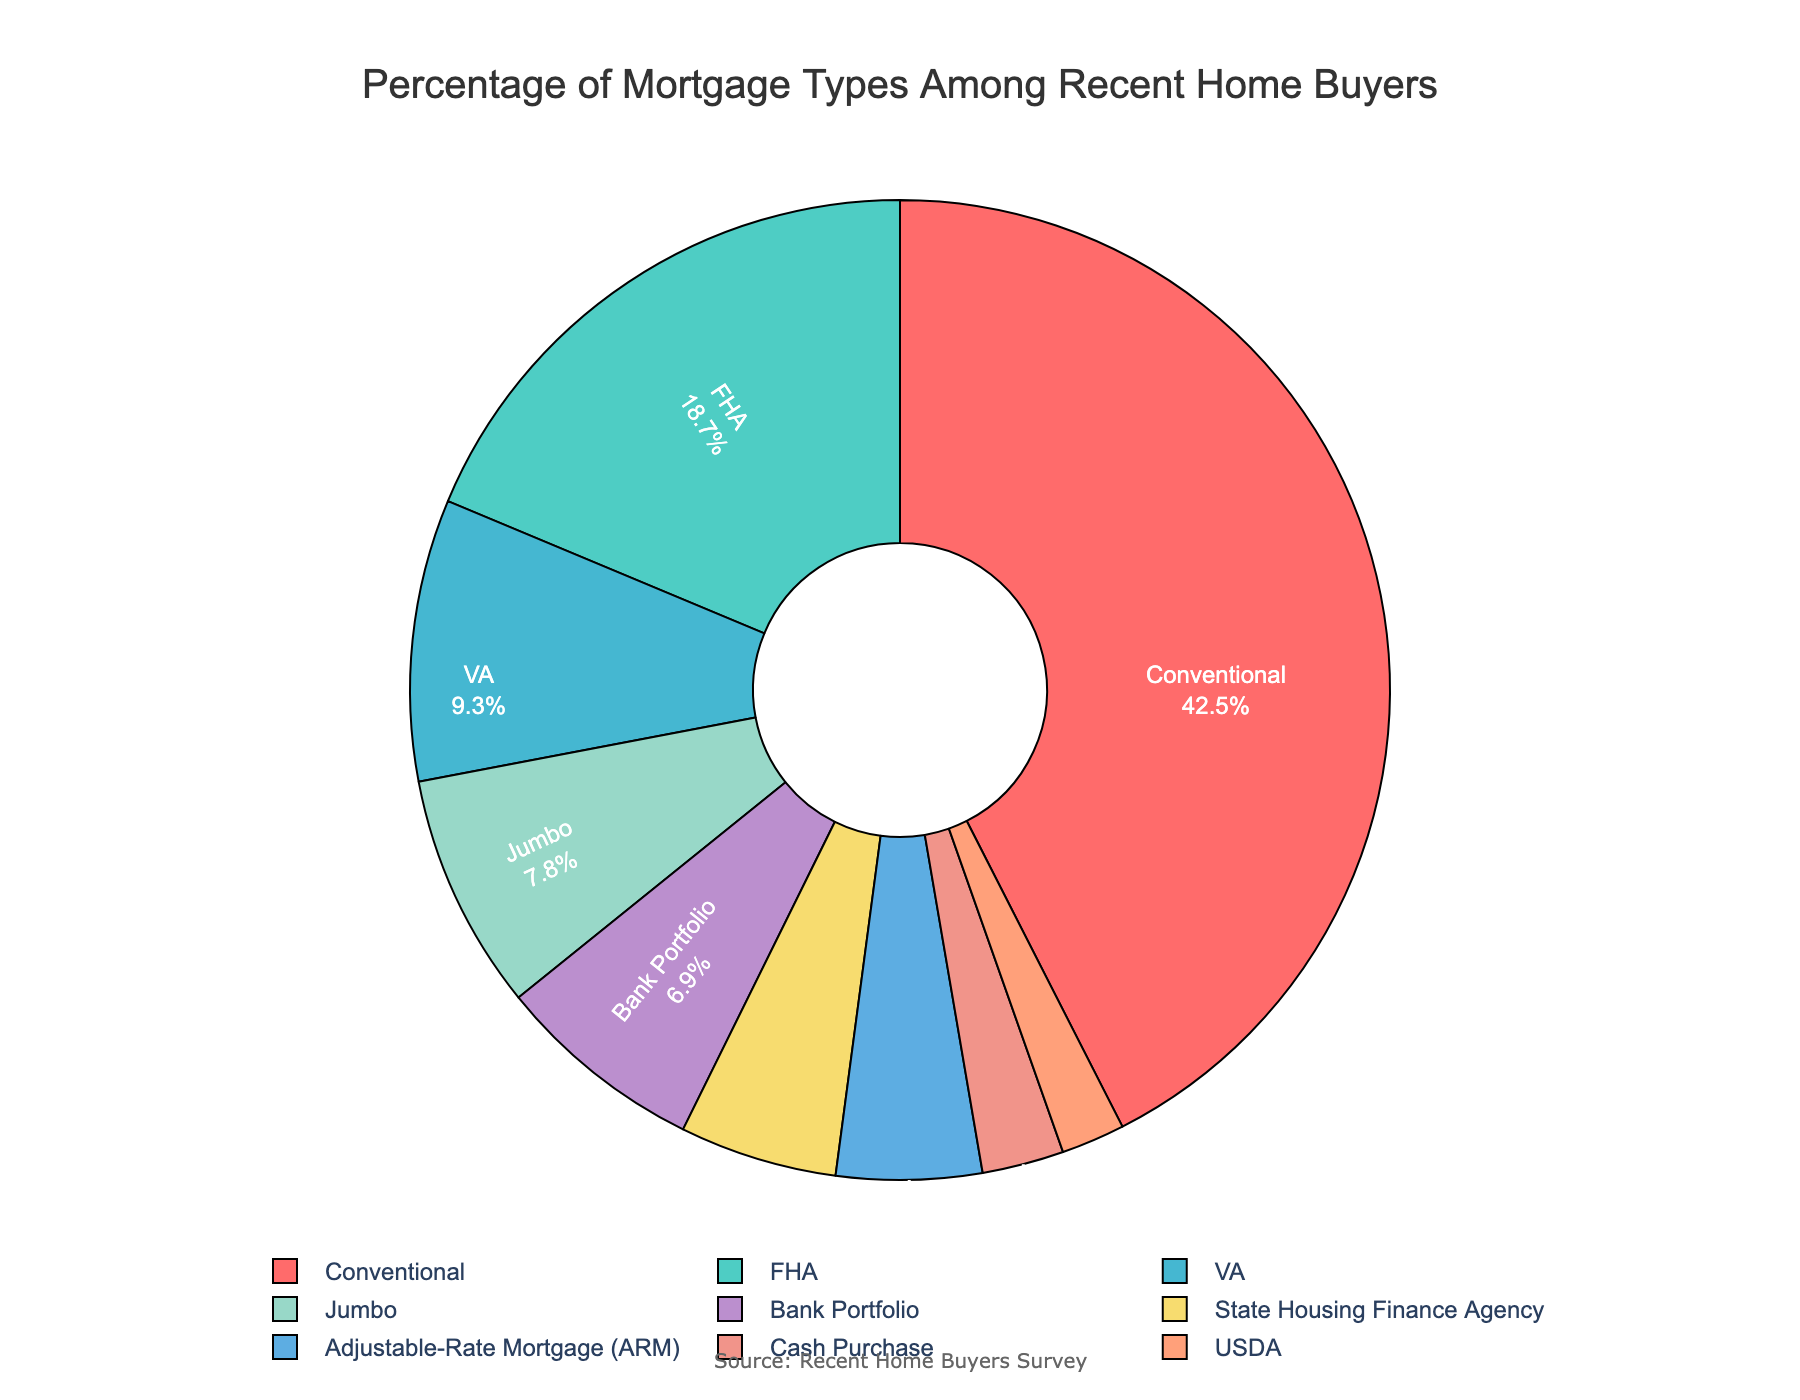What's the percentage of recent home buyers that used Conventional mortgages? The pie chart displays a section labeled "Conventional" with a percentage next to it. By checking the percentage value, we can determine that 42.5% of recent home buyers used Conventional mortgages.
Answer: 42.5% How does the percentage of FHA mortgages compare to VA mortgages? To compare the percentages, look at the sections labeled "FHA" and "VA" and note their values. FHA has 18.7% while VA has 9.3%, so FHA mortgages are more common than VA mortgages.
Answer: FHA is higher What is the sum of the percentages of Bank Portfolio and State Housing Finance Agency mortgages? Find and add the percentages for Bank Portfolio (6.9%) and State Housing Finance Agency (5.2%). The sum would be 6.9% + 5.2% = 12.1%.
Answer: 12.1% Which mortgage type occupies the smallest percentage in the chart? Look at all the segments and identify the smallest percentage. From the chart, "USDA" has the smallest section with 2.1%.
Answer: USDA What is the combined percentage of Conventional, FHA, and VA mortgages? Add up the percentages from the Conventional (42.5%), FHA (18.7%), and VA (9.3%) sections. The combined percentage is 42.5% + 18.7% + 9.3% = 70.5%.
Answer: 70.5% How much greater is the percentage of Adjustable-Rate Mortgage (ARM) compared to Cash Purchase? Subtract the percentage of Cash Purchase (2.7%) from the percentage of ARM (4.8%). The difference is 4.8% - 2.7% = 2.1%.
Answer: 2.1% Which mortgage types occupy more than 10% of the chart? Review the percentages of all segments and identify those greater than 10%. The Conventional mortgage type is the only segment above 10%, with 42.5%.
Answer: Conventional What color represents the Jumbo mortgage segment? Look at the pie chart and identify the segment labeled "Jumbo." According to the provided color palette, this segment is represented by the color orange.
Answer: orange 